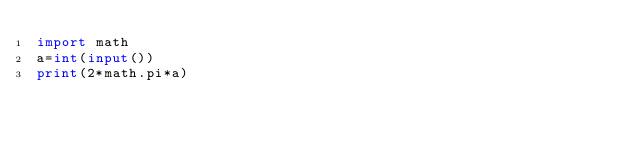Convert code to text. <code><loc_0><loc_0><loc_500><loc_500><_Python_>import math
a=int(input())
print(2*math.pi*a)</code> 